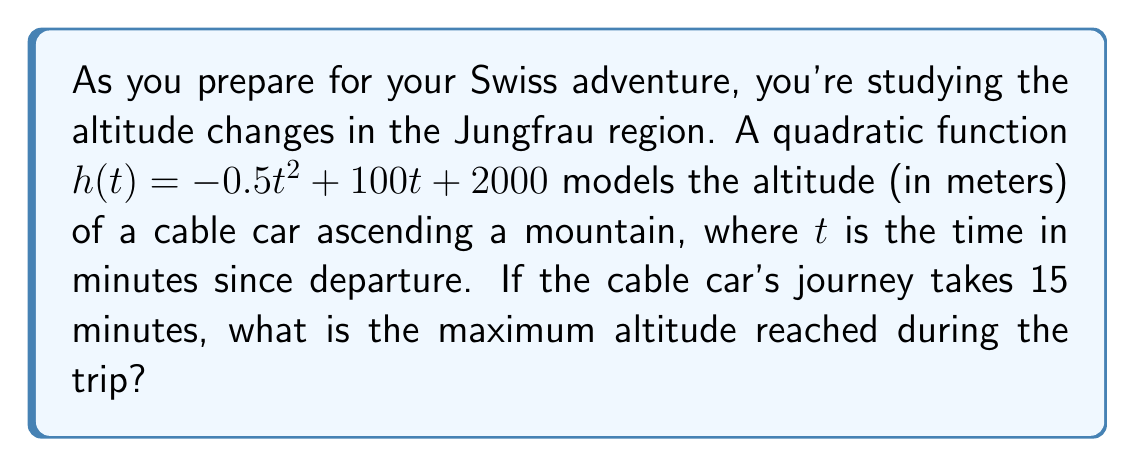Can you solve this math problem? To find the maximum altitude reached by the cable car, we need to determine the vertex of the quadratic function. The vertex represents the highest point of the parabola, which in this case corresponds to the maximum altitude.

For a quadratic function in the form $f(x) = ax^2 + bx + c$, the x-coordinate of the vertex is given by $x = -\frac{b}{2a}$.

In our case, $h(t) = -0.5t^2 + 100t + 2000$, so:

$a = -0.5$
$b = 100$
$c = 2000$

The t-coordinate of the vertex is:

$t = -\frac{b}{2a} = -\frac{100}{2(-0.5)} = \frac{100}{1} = 100$ minutes

However, we're told that the journey only takes 15 minutes. This means the cable car doesn't reach the theoretical maximum of the quadratic function.

To find the maximum altitude within the 15-minute journey, we need to evaluate $h(t)$ at $t = 15$:

$h(15) = -0.5(15)^2 + 100(15) + 2000$
$= -0.5(225) + 1500 + 2000$
$= -112.5 + 1500 + 2000$
$= 3387.5$ meters

Therefore, the maximum altitude reached during the 15-minute trip is 3387.5 meters.
Answer: 3387.5 meters 